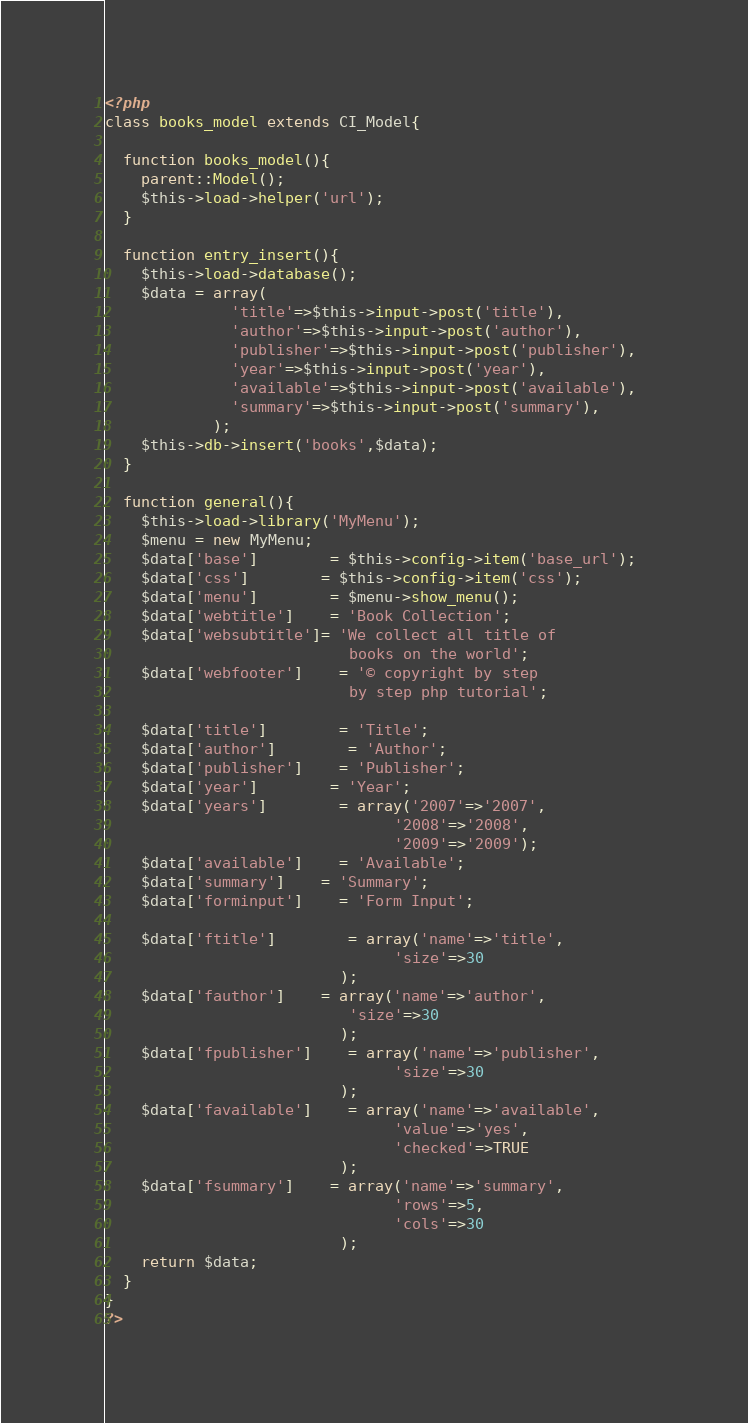<code> <loc_0><loc_0><loc_500><loc_500><_PHP_><?php
class books_model extends CI_Model{
	
  function books_model(){
	parent::Model();
	$this->load->helper('url');				
  }
  
  function entry_insert(){
    $this->load->database();
	$data = array(
	          'title'=>$this->input->post('title'),
			  'author'=>$this->input->post('author'),
			  'publisher'=>$this->input->post('publisher'),
			  'year'=>$this->input->post('year'),
			  'available'=>$this->input->post('available'),
			  'summary'=>$this->input->post('summary'),
	        );
	$this->db->insert('books',$data);
  }
	
  function general(){
	$this->load->library('MyMenu');
	$menu = new MyMenu;
	$data['base']		= $this->config->item('base_url');
	$data['css']		= $this->config->item('css');		
	$data['menu'] 		= $menu->show_menu();
	$data['webtitle']	= 'Book Collection';
	$data['websubtitle']= 'We collect all title of 
		                   books on the world';
	$data['webfooter']	= '© copyright by step 
		                   by step php tutorial';
						   
	$data['title']	 	= 'Title';
	$data['author']	 	= 'Author';
	$data['publisher']	= 'Publisher';				
	$data['year']	 	= 'Year';
	$data['years']	 	= array('2007'=>'2007',
	                            '2008'=>'2008',
								'2009'=>'2009');	
	$data['available']	= 'Available';	
	$data['summary']	= 'Summary';
	$data['forminput']	= 'Form Input';
	
	$data['ftitle']		= array('name'=>'title',
	                            'size'=>30
						  );
	$data['fauthor']	= array('name'=>'author',
	                       'size'=>30
						  );
	$data['fpublisher']	= array('name'=>'publisher',
	                            'size'=>30
						  );
    $data['favailable']	= array('name'=>'available',
	                            'value'=>'yes',
								'checked'=>TRUE
						  );
	$data['fsummary']	= array('name'=>'summary',
	                            'rows'=>5,
								'cols'=>30
						  );			
	return $data;	
  }
}
?></code> 